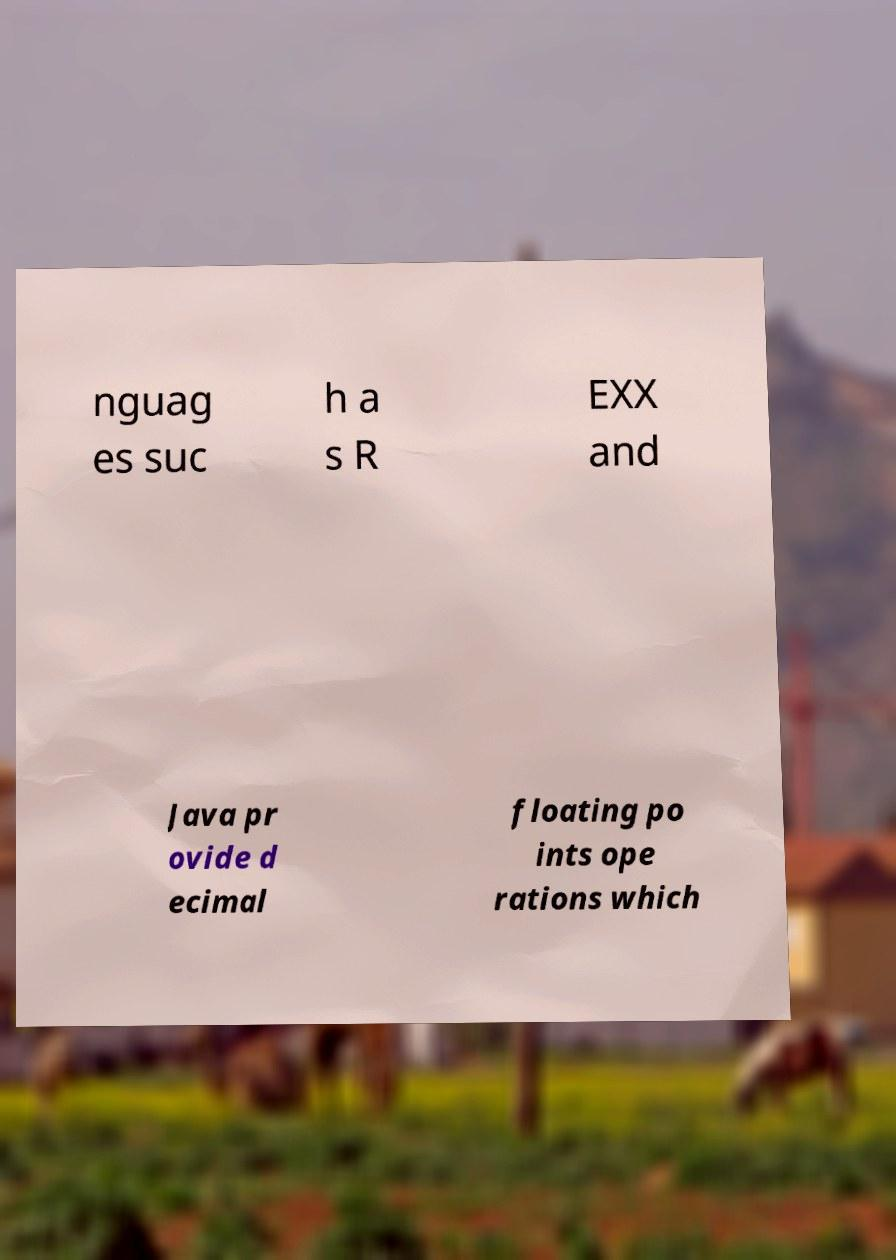For documentation purposes, I need the text within this image transcribed. Could you provide that? nguag es suc h a s R EXX and Java pr ovide d ecimal floating po ints ope rations which 